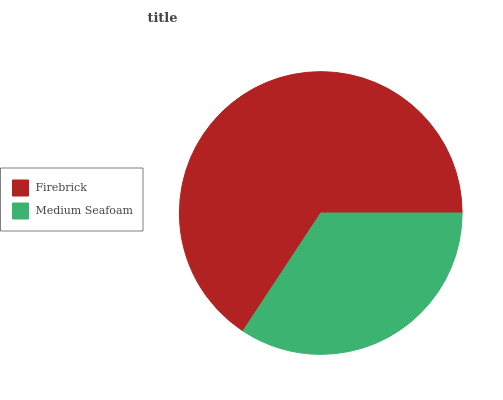Is Medium Seafoam the minimum?
Answer yes or no. Yes. Is Firebrick the maximum?
Answer yes or no. Yes. Is Medium Seafoam the maximum?
Answer yes or no. No. Is Firebrick greater than Medium Seafoam?
Answer yes or no. Yes. Is Medium Seafoam less than Firebrick?
Answer yes or no. Yes. Is Medium Seafoam greater than Firebrick?
Answer yes or no. No. Is Firebrick less than Medium Seafoam?
Answer yes or no. No. Is Firebrick the high median?
Answer yes or no. Yes. Is Medium Seafoam the low median?
Answer yes or no. Yes. Is Medium Seafoam the high median?
Answer yes or no. No. Is Firebrick the low median?
Answer yes or no. No. 